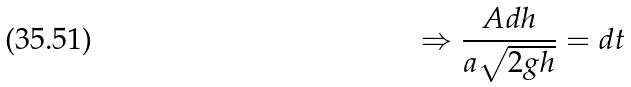Convert formula to latex. <formula><loc_0><loc_0><loc_500><loc_500>\Rightarrow \frac { A d h } { a \sqrt { 2 g h } } = d t</formula> 